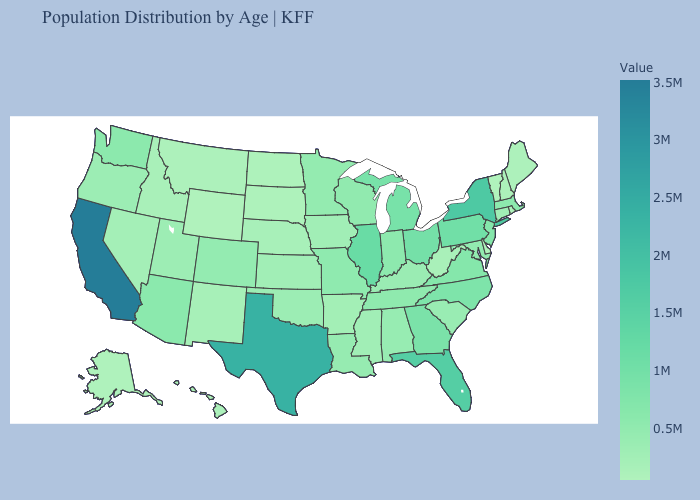Does the map have missing data?
Write a very short answer. No. Does South Carolina have a higher value than Ohio?
Be succinct. No. Among the states that border Tennessee , does North Carolina have the highest value?
Keep it brief. No. Is the legend a continuous bar?
Concise answer only. Yes. Which states have the lowest value in the West?
Short answer required. Wyoming. Does Mississippi have a higher value than Michigan?
Short answer required. No. Does Wyoming have the highest value in the West?
Short answer required. No. Does the map have missing data?
Be succinct. No. 